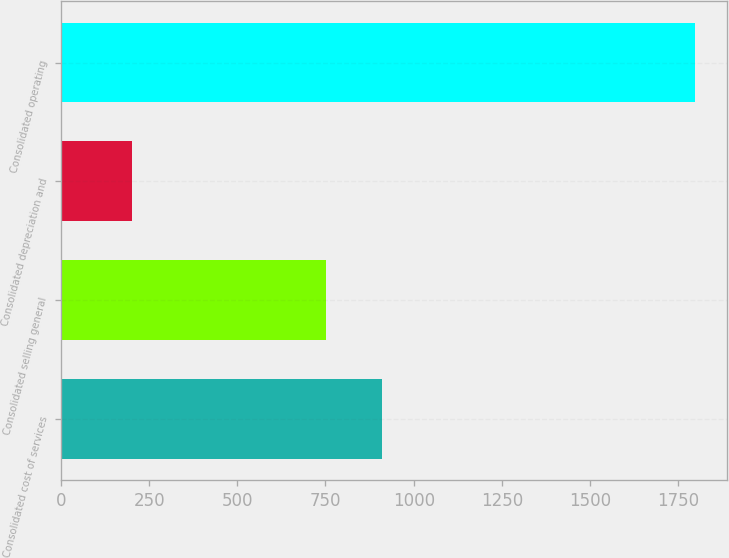Convert chart to OTSL. <chart><loc_0><loc_0><loc_500><loc_500><bar_chart><fcel>Consolidated cost of services<fcel>Consolidated selling general<fcel>Consolidated depreciation and<fcel>Consolidated operating<nl><fcel>911.34<fcel>751.7<fcel>201.8<fcel>1798.2<nl></chart> 